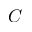<formula> <loc_0><loc_0><loc_500><loc_500>C</formula> 